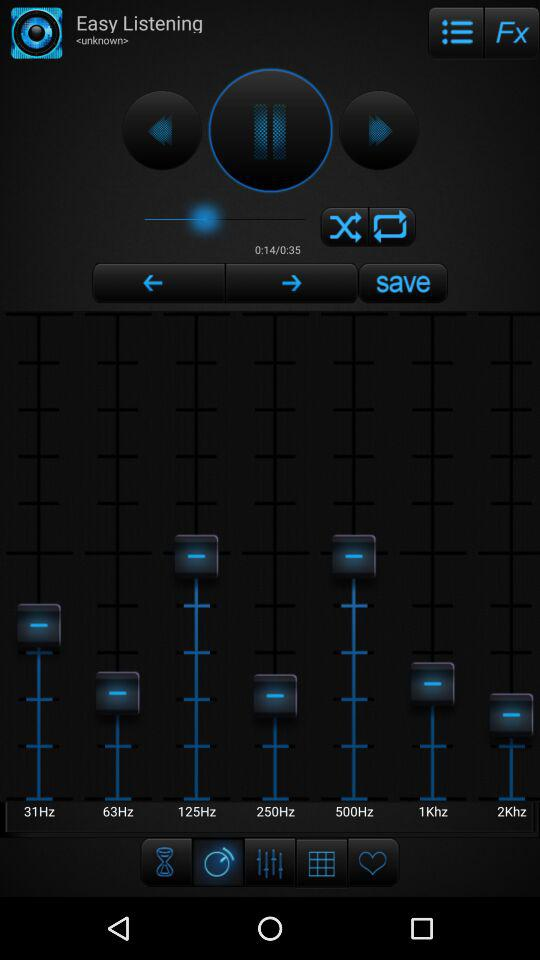How many more seconds are there in the duration of the song than the current playback position?
Answer the question using a single word or phrase. 21 